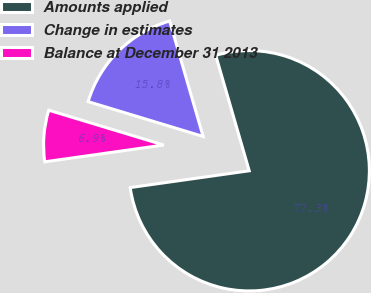Convert chart. <chart><loc_0><loc_0><loc_500><loc_500><pie_chart><fcel>Amounts applied<fcel>Change in estimates<fcel>Balance at December 31 2013<nl><fcel>77.26%<fcel>15.83%<fcel>6.91%<nl></chart> 